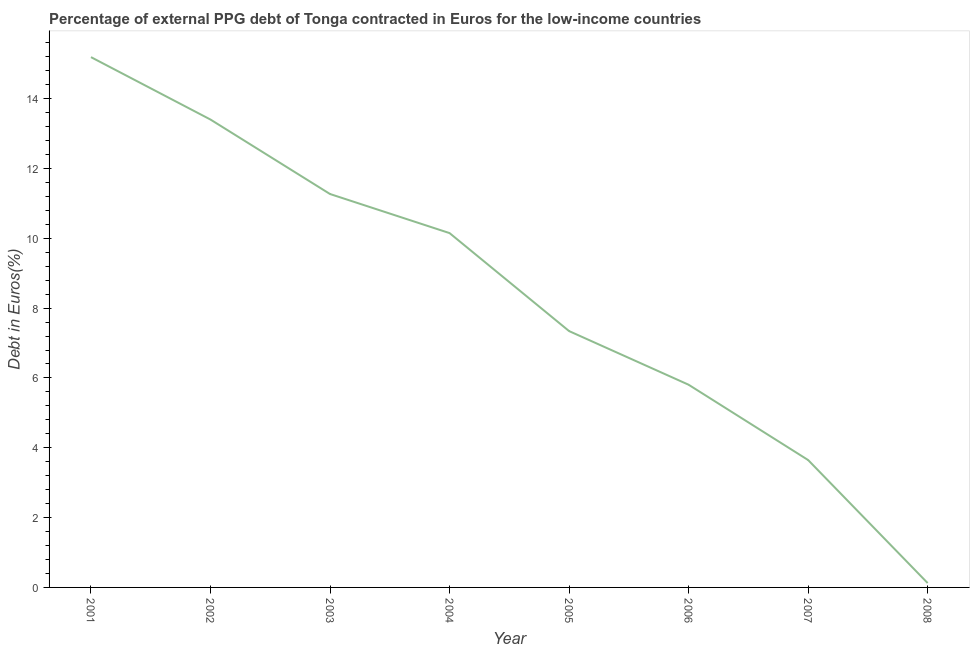What is the currency composition of ppg debt in 2005?
Offer a terse response. 7.34. Across all years, what is the maximum currency composition of ppg debt?
Provide a succinct answer. 15.19. Across all years, what is the minimum currency composition of ppg debt?
Offer a terse response. 0.12. In which year was the currency composition of ppg debt minimum?
Your answer should be compact. 2008. What is the sum of the currency composition of ppg debt?
Offer a very short reply. 66.93. What is the difference between the currency composition of ppg debt in 2004 and 2008?
Offer a terse response. 10.02. What is the average currency composition of ppg debt per year?
Your answer should be very brief. 8.37. What is the median currency composition of ppg debt?
Your answer should be compact. 8.75. In how many years, is the currency composition of ppg debt greater than 4 %?
Offer a very short reply. 6. What is the ratio of the currency composition of ppg debt in 2002 to that in 2004?
Provide a succinct answer. 1.32. What is the difference between the highest and the second highest currency composition of ppg debt?
Offer a very short reply. 1.79. Is the sum of the currency composition of ppg debt in 2004 and 2005 greater than the maximum currency composition of ppg debt across all years?
Keep it short and to the point. Yes. What is the difference between the highest and the lowest currency composition of ppg debt?
Ensure brevity in your answer.  15.07. In how many years, is the currency composition of ppg debt greater than the average currency composition of ppg debt taken over all years?
Offer a very short reply. 4. How many years are there in the graph?
Keep it short and to the point. 8. What is the difference between two consecutive major ticks on the Y-axis?
Ensure brevity in your answer.  2. Does the graph contain any zero values?
Offer a very short reply. No. Does the graph contain grids?
Your answer should be very brief. No. What is the title of the graph?
Provide a succinct answer. Percentage of external PPG debt of Tonga contracted in Euros for the low-income countries. What is the label or title of the X-axis?
Give a very brief answer. Year. What is the label or title of the Y-axis?
Give a very brief answer. Debt in Euros(%). What is the Debt in Euros(%) of 2001?
Give a very brief answer. 15.19. What is the Debt in Euros(%) of 2002?
Give a very brief answer. 13.4. What is the Debt in Euros(%) of 2003?
Ensure brevity in your answer.  11.27. What is the Debt in Euros(%) in 2004?
Provide a short and direct response. 10.15. What is the Debt in Euros(%) in 2005?
Offer a very short reply. 7.34. What is the Debt in Euros(%) in 2006?
Offer a very short reply. 5.81. What is the Debt in Euros(%) in 2007?
Offer a terse response. 3.65. What is the Debt in Euros(%) in 2008?
Provide a short and direct response. 0.12. What is the difference between the Debt in Euros(%) in 2001 and 2002?
Offer a terse response. 1.79. What is the difference between the Debt in Euros(%) in 2001 and 2003?
Ensure brevity in your answer.  3.92. What is the difference between the Debt in Euros(%) in 2001 and 2004?
Offer a terse response. 5.04. What is the difference between the Debt in Euros(%) in 2001 and 2005?
Your answer should be compact. 7.85. What is the difference between the Debt in Euros(%) in 2001 and 2006?
Offer a terse response. 9.38. What is the difference between the Debt in Euros(%) in 2001 and 2007?
Your answer should be compact. 11.54. What is the difference between the Debt in Euros(%) in 2001 and 2008?
Offer a terse response. 15.07. What is the difference between the Debt in Euros(%) in 2002 and 2003?
Your response must be concise. 2.13. What is the difference between the Debt in Euros(%) in 2002 and 2004?
Keep it short and to the point. 3.25. What is the difference between the Debt in Euros(%) in 2002 and 2005?
Offer a very short reply. 6.06. What is the difference between the Debt in Euros(%) in 2002 and 2006?
Make the answer very short. 7.6. What is the difference between the Debt in Euros(%) in 2002 and 2007?
Keep it short and to the point. 9.75. What is the difference between the Debt in Euros(%) in 2002 and 2008?
Make the answer very short. 13.28. What is the difference between the Debt in Euros(%) in 2003 and 2004?
Your answer should be compact. 1.12. What is the difference between the Debt in Euros(%) in 2003 and 2005?
Ensure brevity in your answer.  3.93. What is the difference between the Debt in Euros(%) in 2003 and 2006?
Offer a terse response. 5.46. What is the difference between the Debt in Euros(%) in 2003 and 2007?
Your response must be concise. 7.62. What is the difference between the Debt in Euros(%) in 2003 and 2008?
Your answer should be very brief. 11.14. What is the difference between the Debt in Euros(%) in 2004 and 2005?
Provide a short and direct response. 2.81. What is the difference between the Debt in Euros(%) in 2004 and 2006?
Your answer should be very brief. 4.34. What is the difference between the Debt in Euros(%) in 2004 and 2007?
Your response must be concise. 6.5. What is the difference between the Debt in Euros(%) in 2004 and 2008?
Give a very brief answer. 10.02. What is the difference between the Debt in Euros(%) in 2005 and 2006?
Your answer should be compact. 1.54. What is the difference between the Debt in Euros(%) in 2005 and 2007?
Provide a succinct answer. 3.69. What is the difference between the Debt in Euros(%) in 2005 and 2008?
Offer a terse response. 7.22. What is the difference between the Debt in Euros(%) in 2006 and 2007?
Offer a very short reply. 2.16. What is the difference between the Debt in Euros(%) in 2006 and 2008?
Make the answer very short. 5.68. What is the difference between the Debt in Euros(%) in 2007 and 2008?
Give a very brief answer. 3.52. What is the ratio of the Debt in Euros(%) in 2001 to that in 2002?
Offer a very short reply. 1.13. What is the ratio of the Debt in Euros(%) in 2001 to that in 2003?
Ensure brevity in your answer.  1.35. What is the ratio of the Debt in Euros(%) in 2001 to that in 2004?
Offer a terse response. 1.5. What is the ratio of the Debt in Euros(%) in 2001 to that in 2005?
Provide a succinct answer. 2.07. What is the ratio of the Debt in Euros(%) in 2001 to that in 2006?
Make the answer very short. 2.62. What is the ratio of the Debt in Euros(%) in 2001 to that in 2007?
Give a very brief answer. 4.16. What is the ratio of the Debt in Euros(%) in 2001 to that in 2008?
Offer a very short reply. 121.62. What is the ratio of the Debt in Euros(%) in 2002 to that in 2003?
Offer a very short reply. 1.19. What is the ratio of the Debt in Euros(%) in 2002 to that in 2004?
Keep it short and to the point. 1.32. What is the ratio of the Debt in Euros(%) in 2002 to that in 2005?
Provide a short and direct response. 1.82. What is the ratio of the Debt in Euros(%) in 2002 to that in 2006?
Your answer should be very brief. 2.31. What is the ratio of the Debt in Euros(%) in 2002 to that in 2007?
Ensure brevity in your answer.  3.67. What is the ratio of the Debt in Euros(%) in 2002 to that in 2008?
Your answer should be very brief. 107.3. What is the ratio of the Debt in Euros(%) in 2003 to that in 2004?
Make the answer very short. 1.11. What is the ratio of the Debt in Euros(%) in 2003 to that in 2005?
Your answer should be compact. 1.53. What is the ratio of the Debt in Euros(%) in 2003 to that in 2006?
Make the answer very short. 1.94. What is the ratio of the Debt in Euros(%) in 2003 to that in 2007?
Offer a terse response. 3.09. What is the ratio of the Debt in Euros(%) in 2003 to that in 2008?
Keep it short and to the point. 90.22. What is the ratio of the Debt in Euros(%) in 2004 to that in 2005?
Provide a short and direct response. 1.38. What is the ratio of the Debt in Euros(%) in 2004 to that in 2006?
Keep it short and to the point. 1.75. What is the ratio of the Debt in Euros(%) in 2004 to that in 2007?
Provide a succinct answer. 2.78. What is the ratio of the Debt in Euros(%) in 2004 to that in 2008?
Your answer should be very brief. 81.26. What is the ratio of the Debt in Euros(%) in 2005 to that in 2006?
Make the answer very short. 1.26. What is the ratio of the Debt in Euros(%) in 2005 to that in 2007?
Offer a very short reply. 2.01. What is the ratio of the Debt in Euros(%) in 2005 to that in 2008?
Your response must be concise. 58.79. What is the ratio of the Debt in Euros(%) in 2006 to that in 2007?
Your answer should be compact. 1.59. What is the ratio of the Debt in Euros(%) in 2006 to that in 2008?
Offer a terse response. 46.49. What is the ratio of the Debt in Euros(%) in 2007 to that in 2008?
Your answer should be compact. 29.21. 